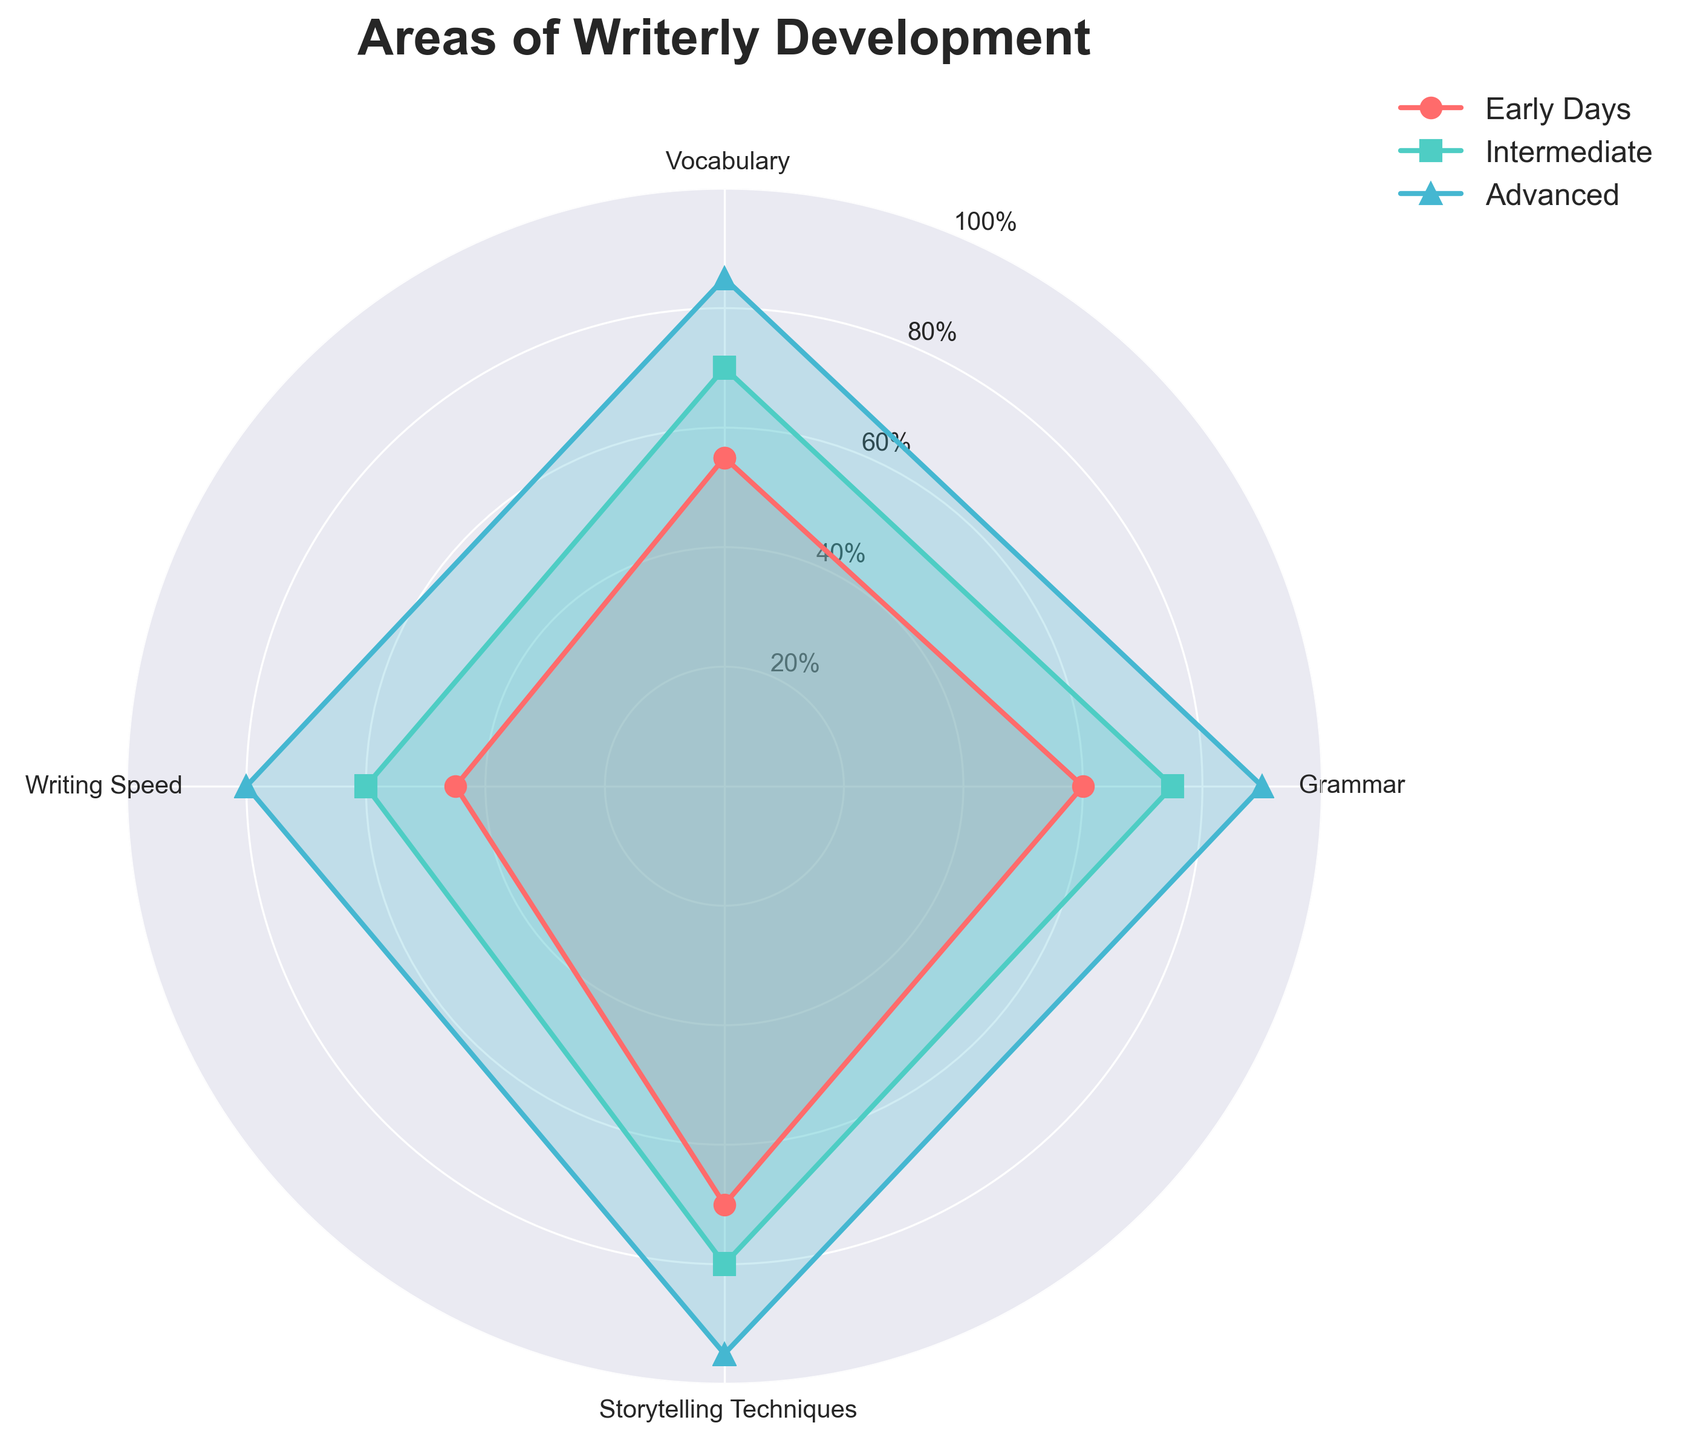What is the title of the radar chart? The title can be found at the top of the radar chart. It reads "Areas of Writerly Development".
Answer: Areas of Writerly Development Which group has the lowest Writing Speed? Look at the values on the 'Writing Speed' axis and observe which group has the lowest plotted point. 'Early Days' has the lowest Writing Speed at 45.
Answer: Early Days How many categories are displayed on the radar chart? Count the number of labels around the radar chart's perimeter. The labels are Vocabulary, Grammar, Storytelling Techniques, and Writing Speed, making it a total of 4 categories.
Answer: 4 What is the average value of Grammar for all groups? Add the Grammar scores for all groups and divide by the number of groups. The scores are 60 (Early Days), 75 (Intermediate), and 90 (Advanced). Average = (60 + 75 + 90) / 3 = 75.
Answer: 75 What's the difference in Vocabulary between Early Days and Advanced? Subtract the Early Days value from the Advanced value for Vocabulary. 85 (Advanced) - 55 (Early Days) = 30.
Answer: 30 Which group has made the biggest improvement in Writing Speed from Early Days to Advanced? Compare the Writing Speed values for the Early Days and Advanced groups. Early Days is 45 and Advanced is 80. The improvement is 80 - 45 = 35.
Answer: Advanced Between which two groups is the smallest difference in Storytelling Techniques? Calculate the differences in Storytelling Techniques between each pair. Differences are: 
Early Days - Intermediate = 80 - 70 = 10,
Intermediate - Advanced = 95 - 80 = 15,
Early Days - Advanced = 95 - 70 = 25.
The smallest difference is between Early Days and Intermediate (10).
Answer: Early Days and Intermediate Which category shows the most balanced development across all groups? The most balanced category would have the smallest range between the highest and lowest values. The ranges are:
Vocabulary (85-55=30),
Grammar (90-60=30),
Storytelling Techniques (95-70=25),
Writing Speed (80-45=35).
Storytelling Techniques have the smallest range (25).
Answer: Storytelling Techniques 